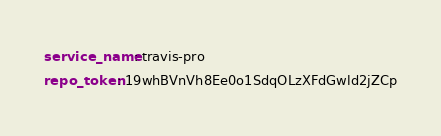<code> <loc_0><loc_0><loc_500><loc_500><_YAML_>service_name: travis-pro
repo_token: 19whBVnVh8Ee0o1SdqOLzXFdGwld2jZCp

</code> 